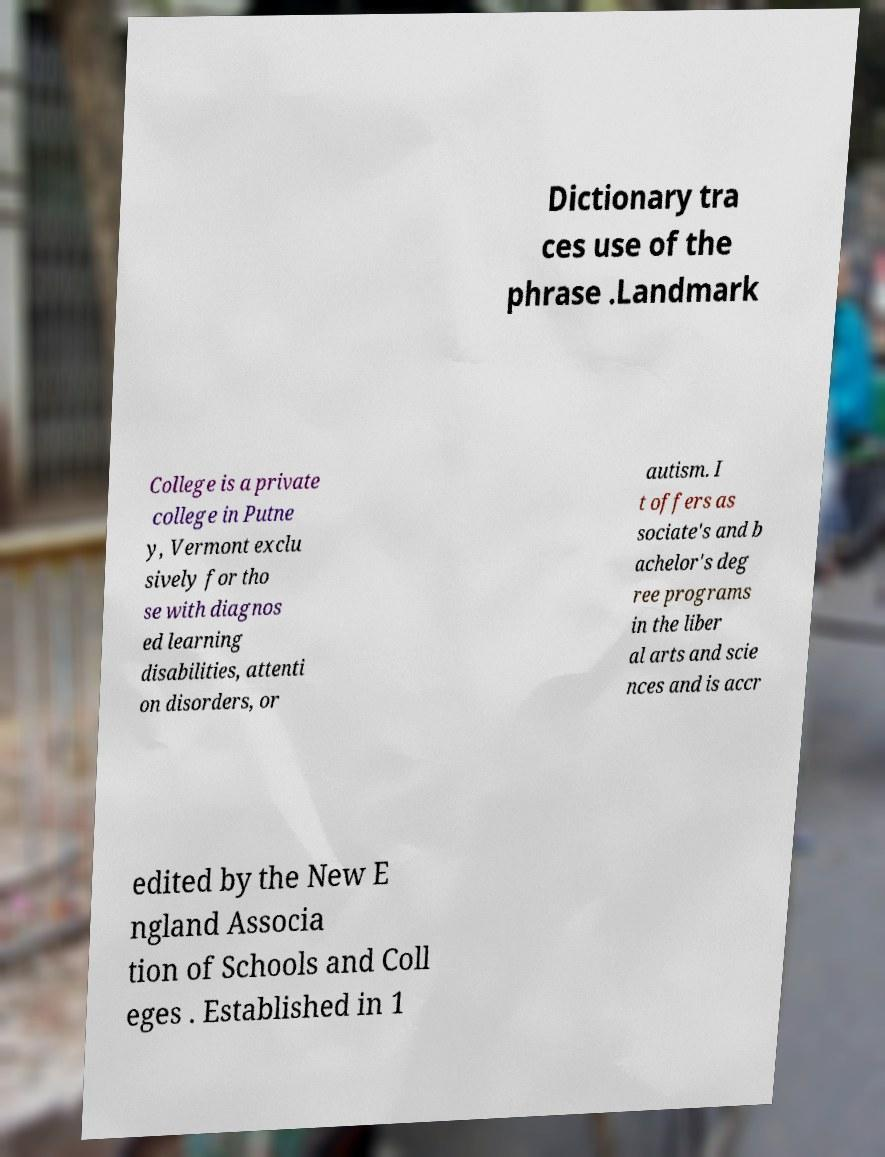I need the written content from this picture converted into text. Can you do that? Dictionary tra ces use of the phrase .Landmark College is a private college in Putne y, Vermont exclu sively for tho se with diagnos ed learning disabilities, attenti on disorders, or autism. I t offers as sociate's and b achelor's deg ree programs in the liber al arts and scie nces and is accr edited by the New E ngland Associa tion of Schools and Coll eges . Established in 1 